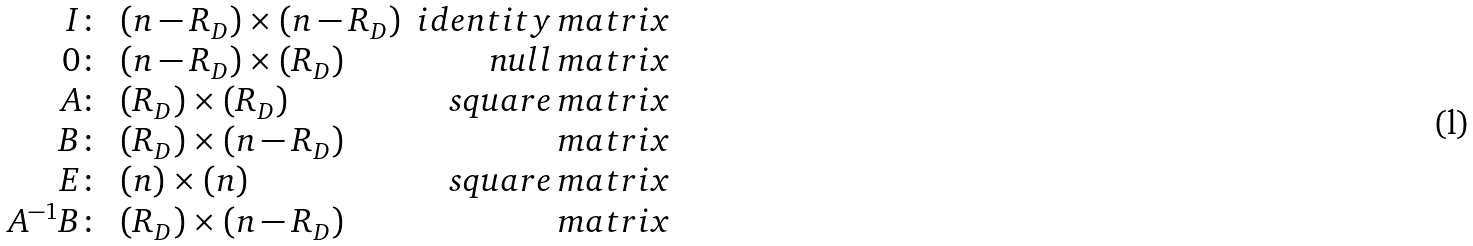<formula> <loc_0><loc_0><loc_500><loc_500>\begin{array} { r l r } I \colon & ( n - R _ { D } ) \times ( n - R _ { D } ) & i d e n t i t y \, m a t r i x \\ 0 \colon & ( n - R _ { D } ) \times ( R _ { D } ) & n u l l \, m a t r i x \\ A \colon & ( R _ { D } ) \times ( R _ { D } ) & s q u a r e \, m a t r i x \\ B \colon & ( R _ { D } ) \times ( n - R _ { D } ) & \, m a t r i x \\ E \colon & ( n ) \times ( n ) & s q u a r e \, m a t r i x \\ A ^ { - 1 } B \colon & ( R _ { D } ) \times ( n - R _ { D } ) & \, m a t r i x \end{array}</formula> 